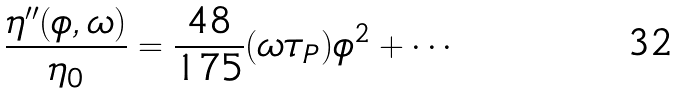<formula> <loc_0><loc_0><loc_500><loc_500>\frac { \eta ^ { \prime \prime } ( \phi , \omega ) } { \eta _ { 0 } } = \frac { 4 8 } { 1 7 5 } ( \omega \tau _ { P } ) \phi ^ { 2 } + \cdots</formula> 